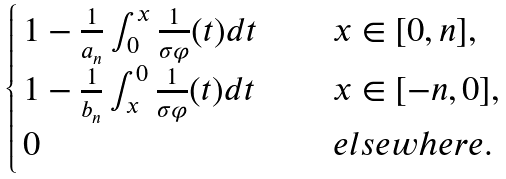Convert formula to latex. <formula><loc_0><loc_0><loc_500><loc_500>\begin{cases} \, 1 - \frac { 1 } { a _ { n } } \int _ { 0 } ^ { x } \frac { 1 } { \sigma \varphi } ( t ) d t \quad \, & x \in [ 0 , n ] , \\ \, 1 - \frac { 1 } { b _ { n } } \int _ { x } ^ { 0 } \frac { 1 } { \sigma \varphi } ( t ) d t & x \in [ - n , 0 ] , \\ \, 0 & e l s e w h e r e . \end{cases}</formula> 